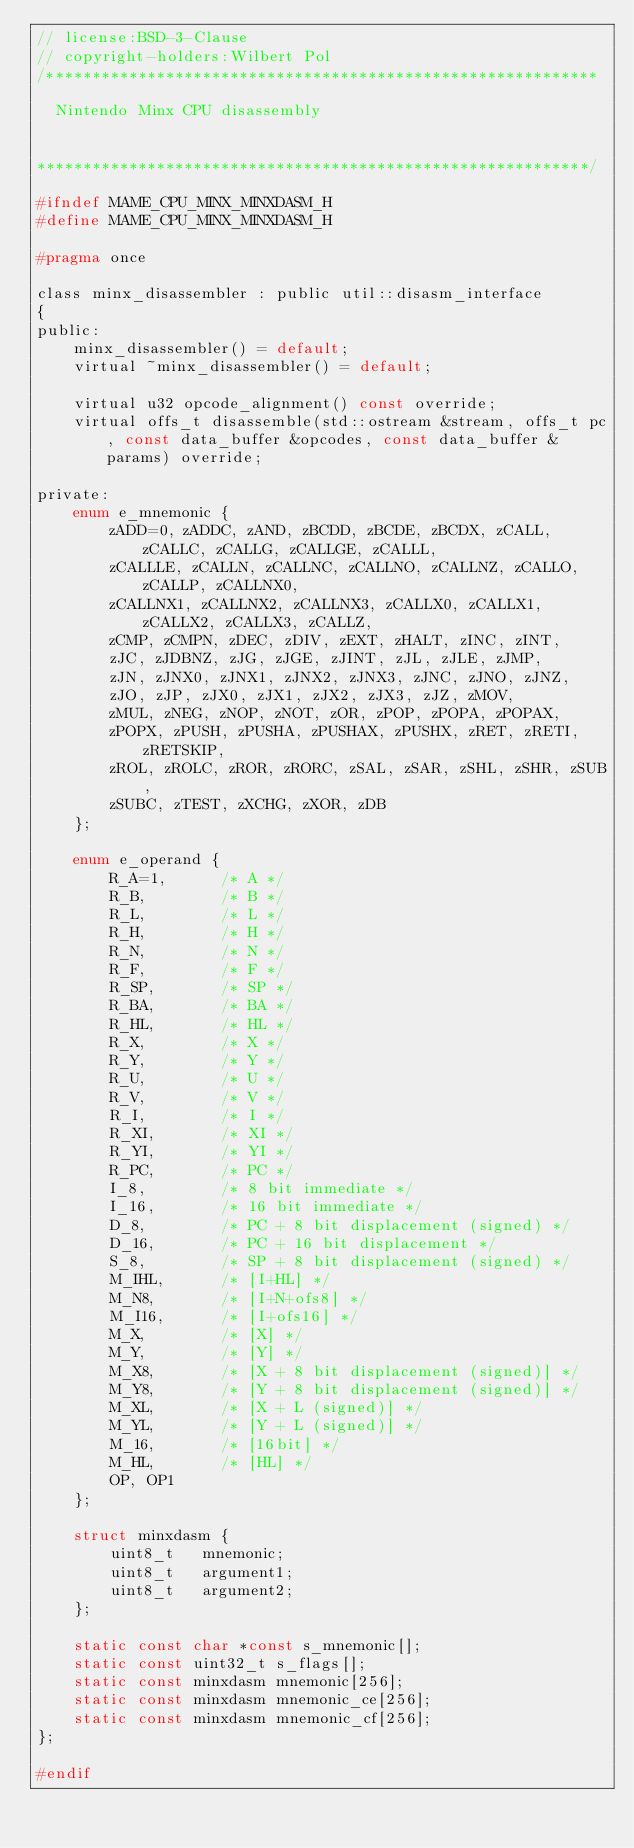<code> <loc_0><loc_0><loc_500><loc_500><_C_>// license:BSD-3-Clause
// copyright-holders:Wilbert Pol
/************************************************************

  Nintendo Minx CPU disassembly


************************************************************/

#ifndef MAME_CPU_MINX_MINXDASM_H
#define MAME_CPU_MINX_MINXDASM_H

#pragma once

class minx_disassembler : public util::disasm_interface
{
public:
	minx_disassembler() = default;
	virtual ~minx_disassembler() = default;

	virtual u32 opcode_alignment() const override;
	virtual offs_t disassemble(std::ostream &stream, offs_t pc, const data_buffer &opcodes, const data_buffer &params) override;

private:
	enum e_mnemonic {
		zADD=0, zADDC, zAND, zBCDD, zBCDE, zBCDX, zCALL, zCALLC, zCALLG, zCALLGE, zCALLL,
		zCALLLE, zCALLN, zCALLNC, zCALLNO, zCALLNZ, zCALLO, zCALLP, zCALLNX0,
		zCALLNX1, zCALLNX2, zCALLNX3, zCALLX0, zCALLX1, zCALLX2, zCALLX3, zCALLZ,
		zCMP, zCMPN, zDEC, zDIV, zEXT, zHALT, zINC, zINT,
		zJC, zJDBNZ, zJG, zJGE, zJINT, zJL, zJLE, zJMP,
		zJN, zJNX0, zJNX1, zJNX2, zJNX3, zJNC, zJNO, zJNZ,
		zJO, zJP, zJX0, zJX1, zJX2, zJX3, zJZ, zMOV,
		zMUL, zNEG, zNOP, zNOT, zOR, zPOP, zPOPA, zPOPAX,
		zPOPX, zPUSH, zPUSHA, zPUSHAX, zPUSHX, zRET, zRETI, zRETSKIP,
		zROL, zROLC, zROR, zRORC, zSAL, zSAR, zSHL, zSHR, zSUB,
		zSUBC, zTEST, zXCHG, zXOR, zDB
	};

	enum e_operand {
		R_A=1,      /* A */
		R_B,        /* B */
		R_L,        /* L */
		R_H,        /* H */
		R_N,        /* N */
		R_F,        /* F */
		R_SP,       /* SP */
		R_BA,       /* BA */
		R_HL,       /* HL */
		R_X,        /* X */
		R_Y,        /* Y */
		R_U,        /* U */
		R_V,        /* V */
		R_I,        /* I */
		R_XI,       /* XI */
		R_YI,       /* YI */
		R_PC,       /* PC */
		I_8,        /* 8 bit immediate */
		I_16,       /* 16 bit immediate */
		D_8,        /* PC + 8 bit displacement (signed) */
		D_16,       /* PC + 16 bit displacement */
		S_8,        /* SP + 8 bit displacement (signed) */
		M_IHL,      /* [I+HL] */
		M_N8,       /* [I+N+ofs8] */
		M_I16,      /* [I+ofs16] */
		M_X,        /* [X] */
		M_Y,        /* [Y] */
		M_X8,       /* [X + 8 bit displacement (signed)] */
		M_Y8,       /* [Y + 8 bit displacement (signed)] */
		M_XL,       /* [X + L (signed)] */
		M_YL,       /* [Y + L (signed)] */
		M_16,       /* [16bit] */
		M_HL,       /* [HL] */
		OP, OP1
	};

	struct minxdasm {
		uint8_t   mnemonic;
		uint8_t   argument1;
		uint8_t   argument2;
	};

	static const char *const s_mnemonic[];
	static const uint32_t s_flags[];
	static const minxdasm mnemonic[256];
	static const minxdasm mnemonic_ce[256];
	static const minxdasm mnemonic_cf[256];
};

#endif
</code> 